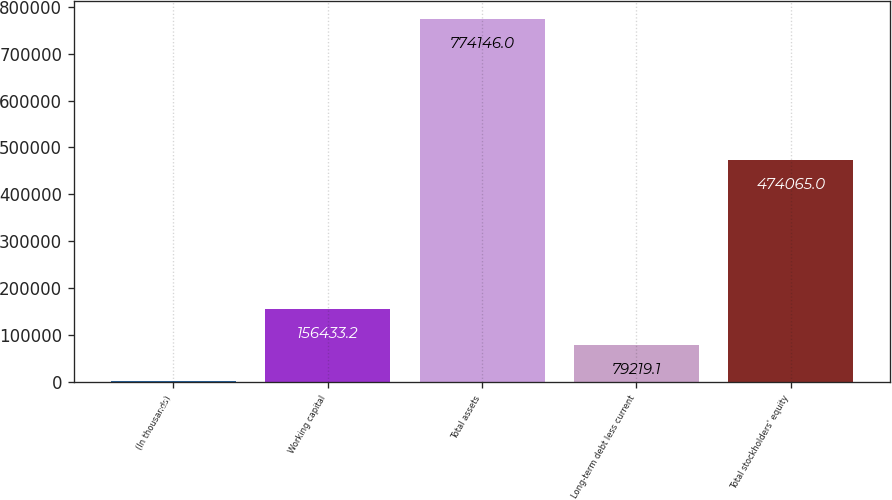<chart> <loc_0><loc_0><loc_500><loc_500><bar_chart><fcel>(In thousands)<fcel>Working capital<fcel>Total assets<fcel>Long-term debt less current<fcel>Total stockholders' equity<nl><fcel>2005<fcel>156433<fcel>774146<fcel>79219.1<fcel>474065<nl></chart> 